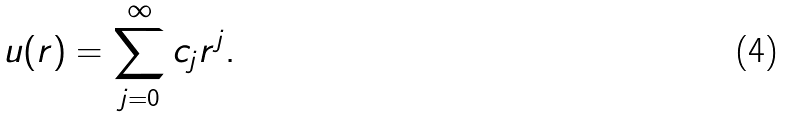Convert formula to latex. <formula><loc_0><loc_0><loc_500><loc_500>u ( r ) = \sum _ { j = 0 } ^ { \infty } c _ { j } r ^ { j } .</formula> 